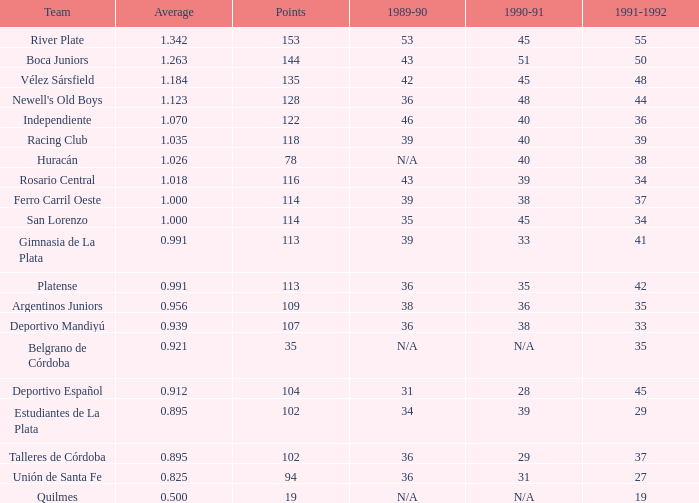How many 1991-1992 have a 1989-90 amount of 36 and an average of 0.0. 